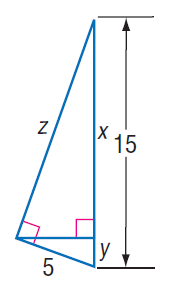Answer the mathemtical geometry problem and directly provide the correct option letter.
Question: Find z.
Choices: A: 2 B: 3 C: 10 D: 10 \sqrt { 2 } D 